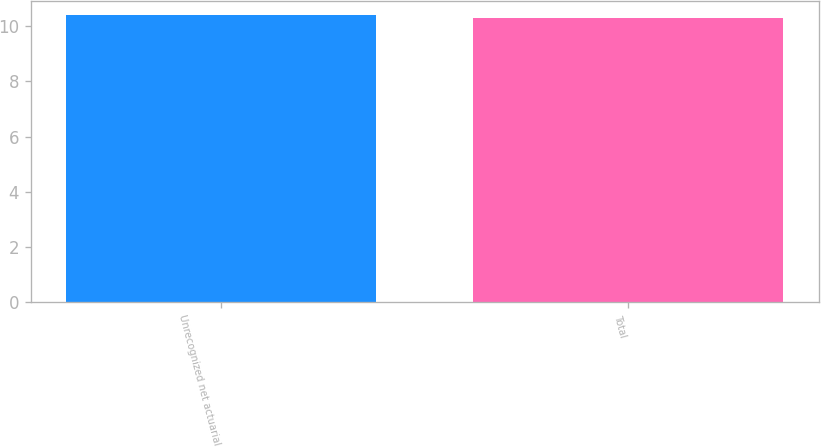Convert chart to OTSL. <chart><loc_0><loc_0><loc_500><loc_500><bar_chart><fcel>Unrecognized net actuarial<fcel>Total<nl><fcel>10.4<fcel>10.3<nl></chart> 